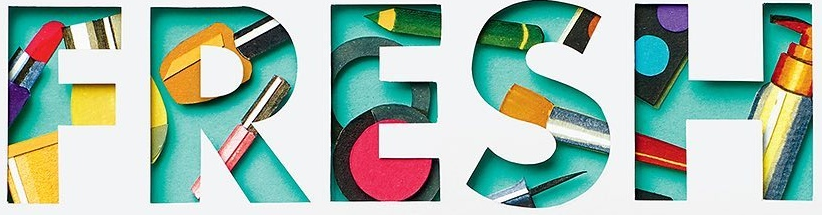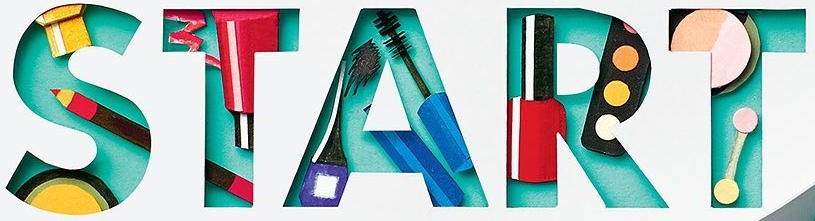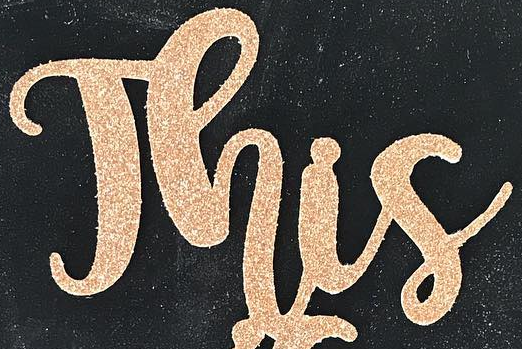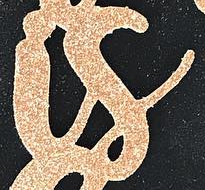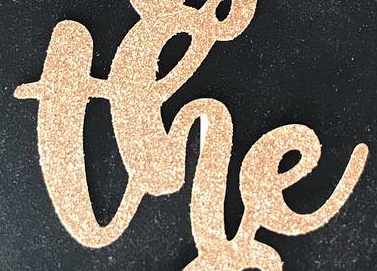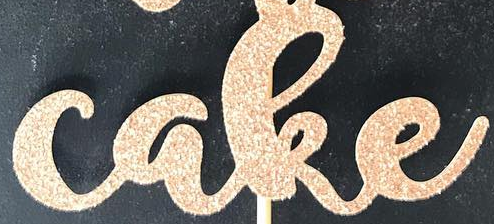Transcribe the words shown in these images in order, separated by a semicolon. FRESH; START; This; is; the; cake 